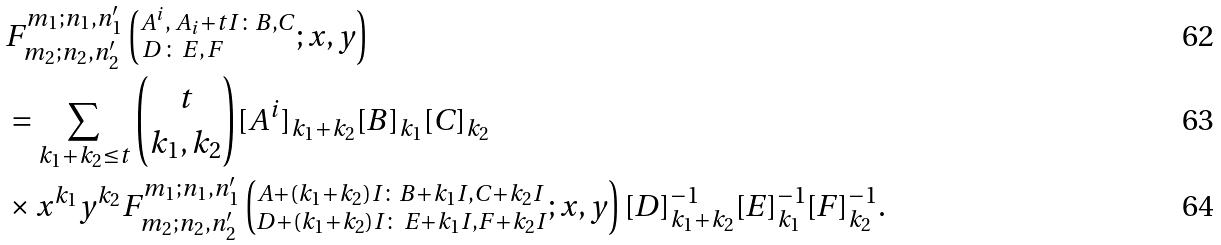Convert formula to latex. <formula><loc_0><loc_0><loc_500><loc_500>& F ^ { m _ { 1 } ; n _ { 1 } , n ^ { \prime } _ { 1 } } _ { m _ { 2 } ; n _ { 2 } , n ^ { \prime } _ { 2 } } \left ( ^ { A ^ { i } , \, A _ { i } + t I \colon B , C } _ { \, D \, \colon \, E , \, F } ; x , y \right ) \\ & = \sum _ { k _ { 1 } + k _ { 2 } \leq t } { t \choose k _ { 1 } , k _ { 2 } } { [ A ^ { i } ] _ { k _ { 1 } + k _ { 2 } } [ B ] _ { k _ { 1 } } } [ C ] _ { k _ { 2 } } \, \\ & \times x ^ { k _ { 1 } } y ^ { k _ { 2 } } F ^ { m _ { 1 } ; n _ { 1 } , n ^ { \prime } _ { 1 } } _ { m _ { 2 } ; n _ { 2 } , n ^ { \prime } _ { 2 } } \left ( ^ { A + ( k _ { 1 } + k _ { 2 } ) I \colon B + k _ { 1 } I , C + k _ { 2 } I } _ { D + ( k _ { 1 } + k _ { 2 } ) I \colon \, E + k _ { 1 } I , F + k _ { 2 } I } ; x , y \right ) { [ D ] ^ { - 1 } _ { k _ { 1 } + k _ { 2 } } [ E ] ^ { - 1 } _ { k _ { 1 } } [ F ] ^ { - 1 } _ { k _ { 2 } } } .</formula> 